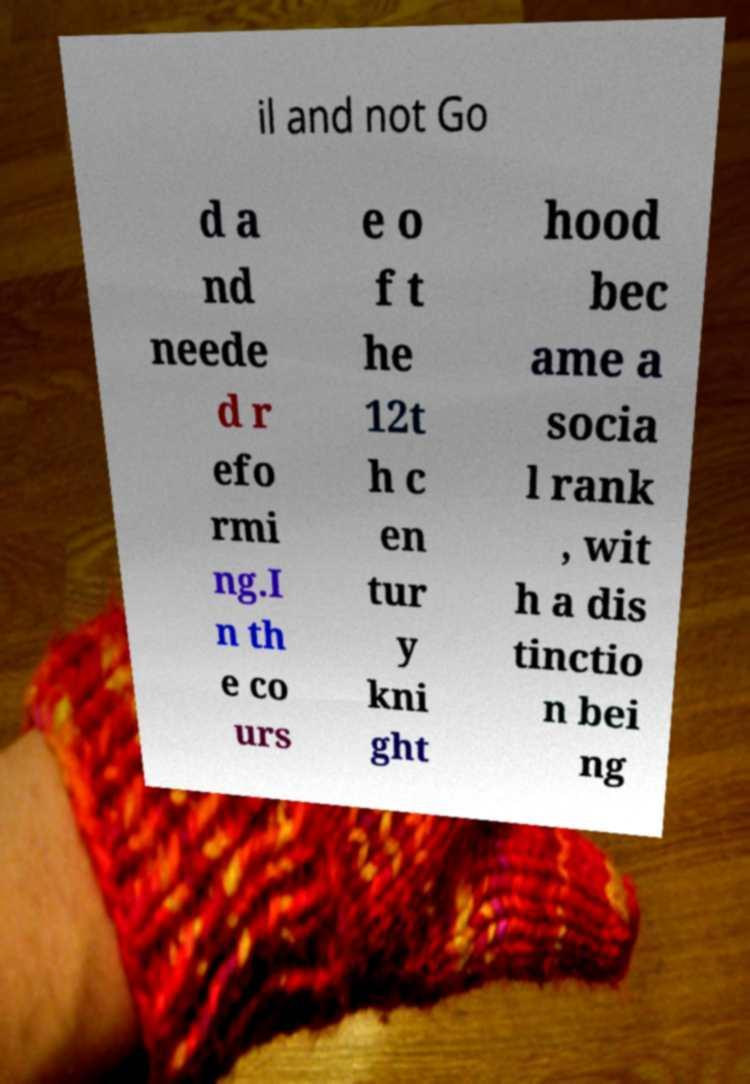Can you accurately transcribe the text from the provided image for me? il and not Go d a nd neede d r efo rmi ng.I n th e co urs e o f t he 12t h c en tur y kni ght hood bec ame a socia l rank , wit h a dis tinctio n bei ng 